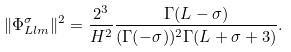<formula> <loc_0><loc_0><loc_500><loc_500>\| \Phi _ { L l m } ^ { \sigma } \| ^ { 2 } = \frac { 2 ^ { 3 } } { H ^ { 2 } } \frac { \Gamma ( L - \sigma ) } { ( \Gamma ( - \sigma ) ) ^ { 2 } \Gamma ( L + \sigma + 3 ) } .</formula> 